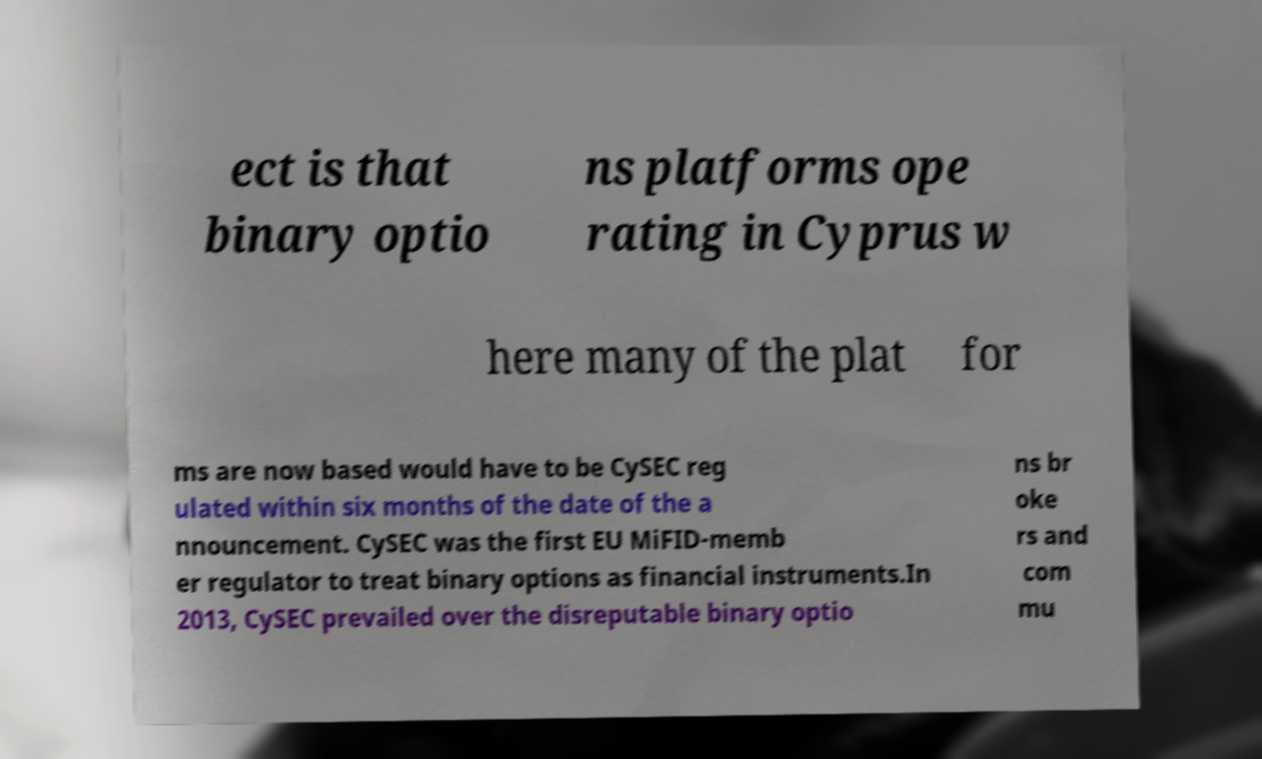Can you accurately transcribe the text from the provided image for me? ect is that binary optio ns platforms ope rating in Cyprus w here many of the plat for ms are now based would have to be CySEC reg ulated within six months of the date of the a nnouncement. CySEC was the first EU MiFID-memb er regulator to treat binary options as financial instruments.In 2013, CySEC prevailed over the disreputable binary optio ns br oke rs and com mu 